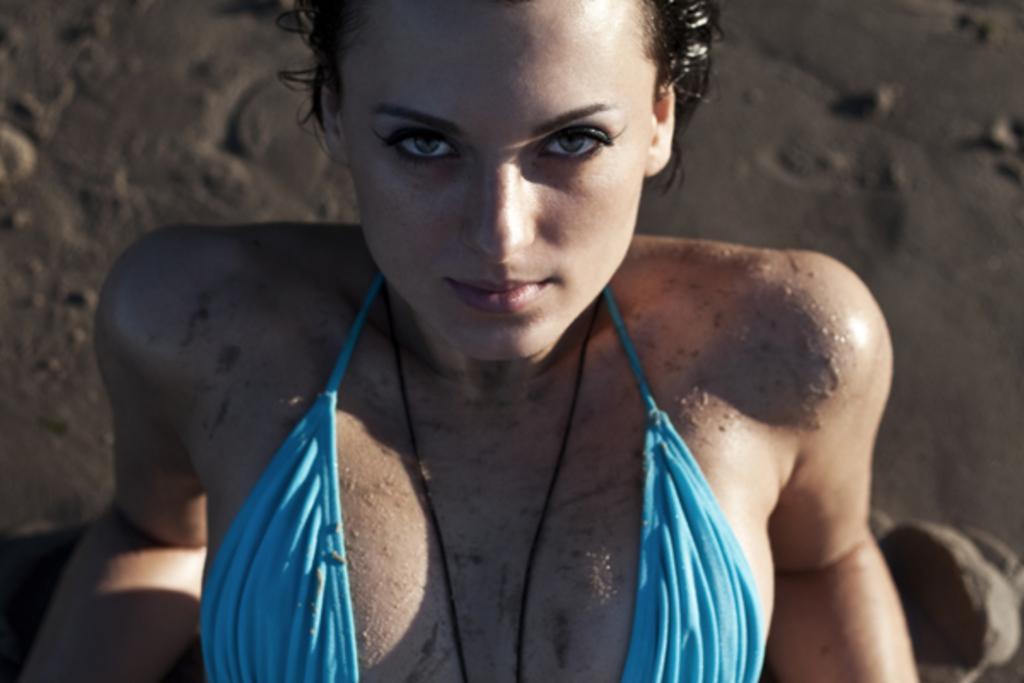Describe this image in one or two sentences. In this image I can see a person is wearing blue color dress. Back I can see the sand. 